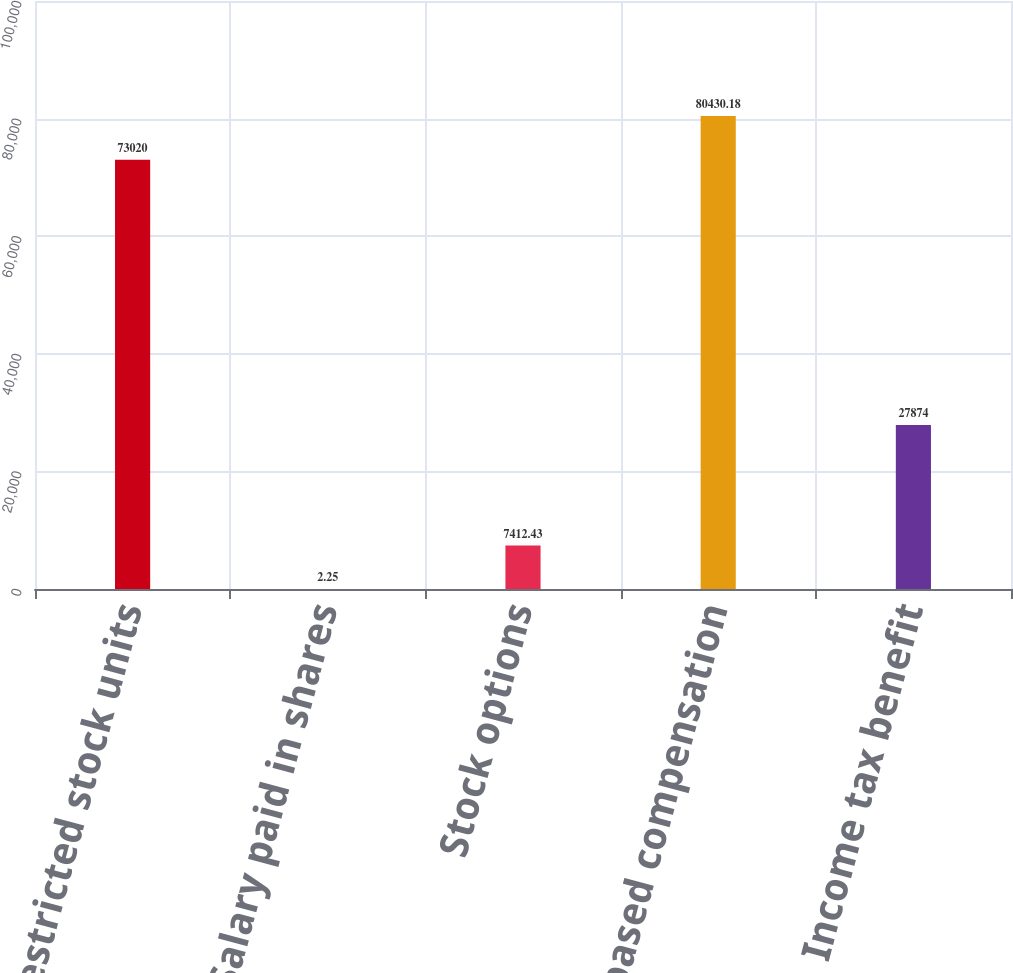<chart> <loc_0><loc_0><loc_500><loc_500><bar_chart><fcel>Restricted stock units<fcel>Salary paid in shares<fcel>Stock options<fcel>Total stock-based compensation<fcel>Income tax benefit<nl><fcel>73020<fcel>2.25<fcel>7412.43<fcel>80430.2<fcel>27874<nl></chart> 